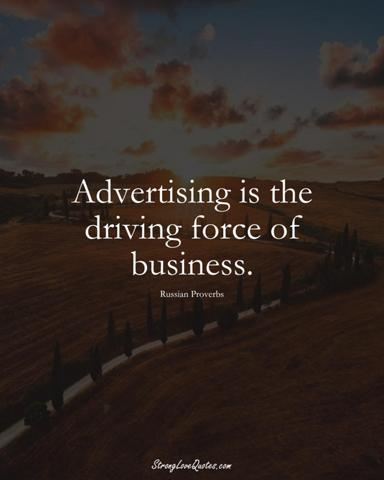What does the phrase "Advertising is the driving force of business" mean?
 The phrase "Advertising is the driving force of business" means that advertising plays a crucial role in promoting and sustaining businesses. Good advertising can attract customers, increase sales, and build brand recognition. Essentially, advertising helps fuel the growth and success of a business. 